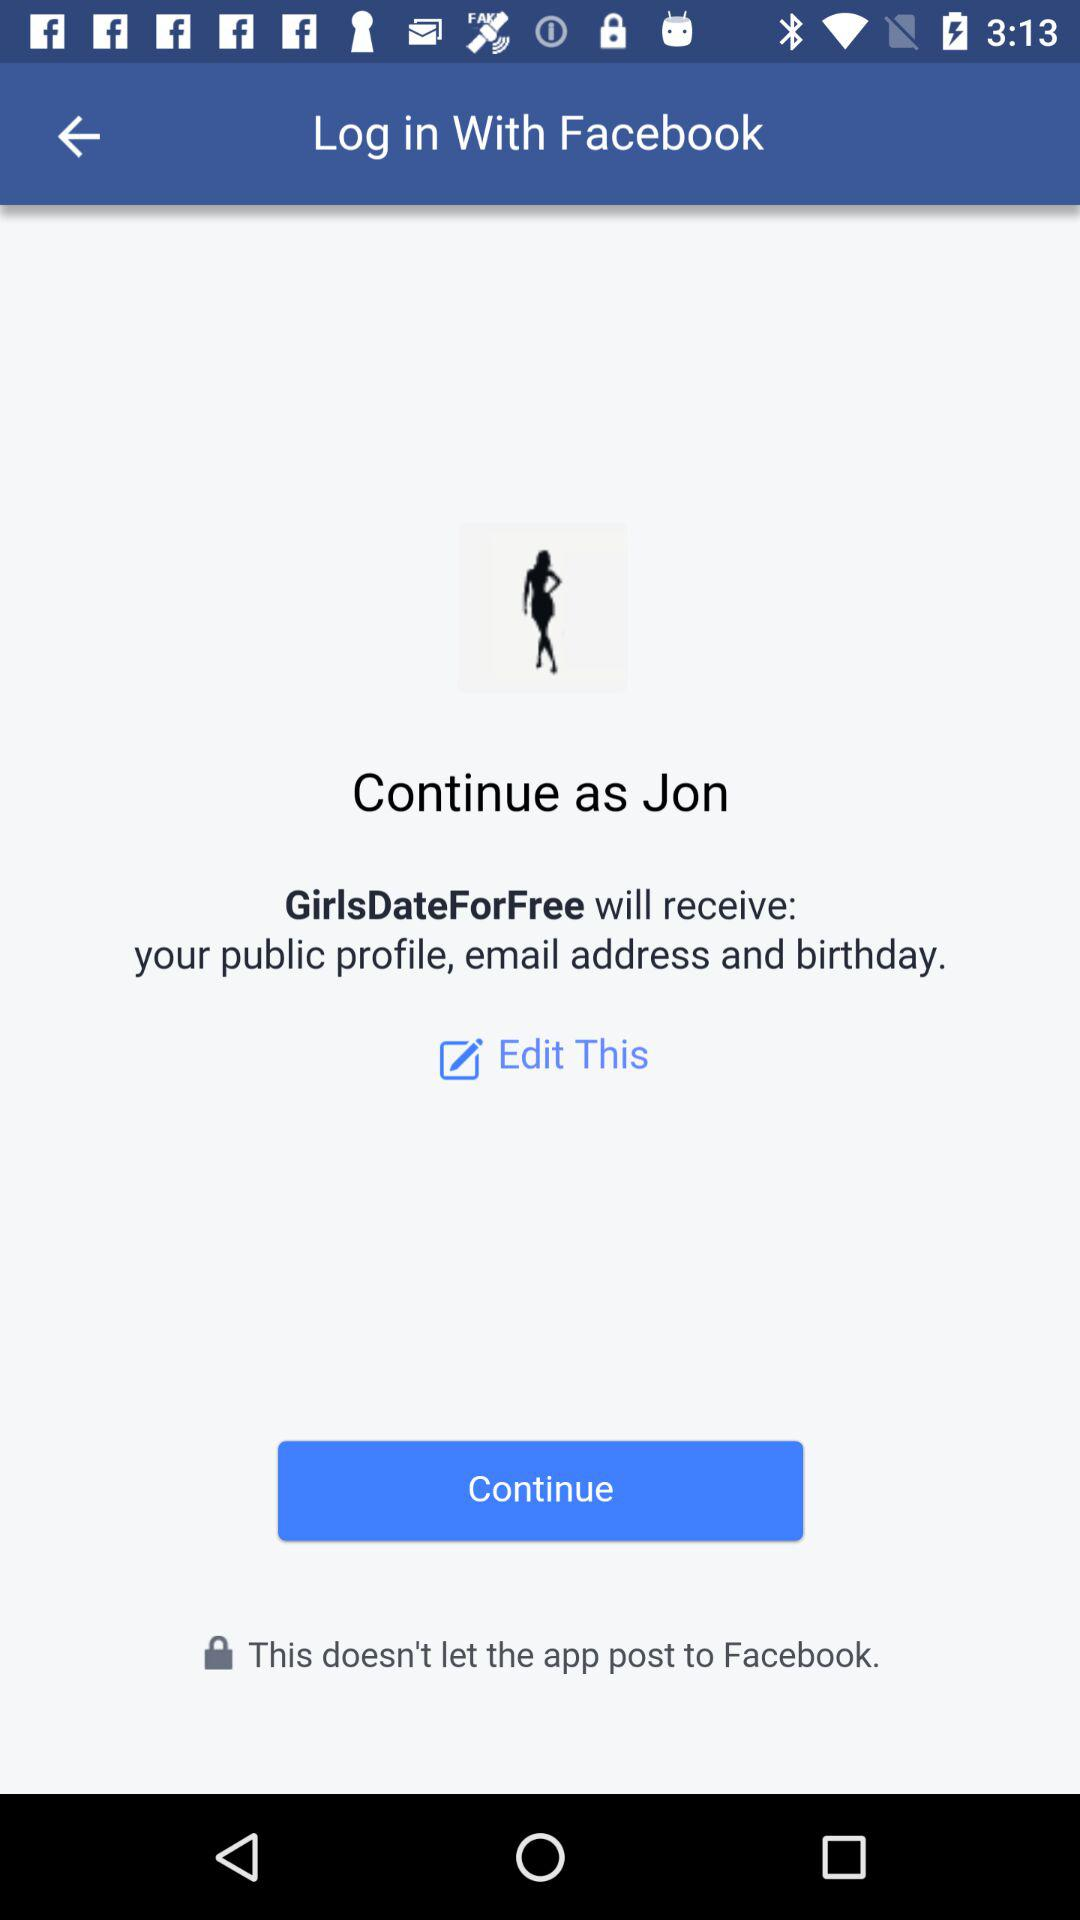What application will receive my public profile, email address and birthday? The application is "GirlsDateForFree". 